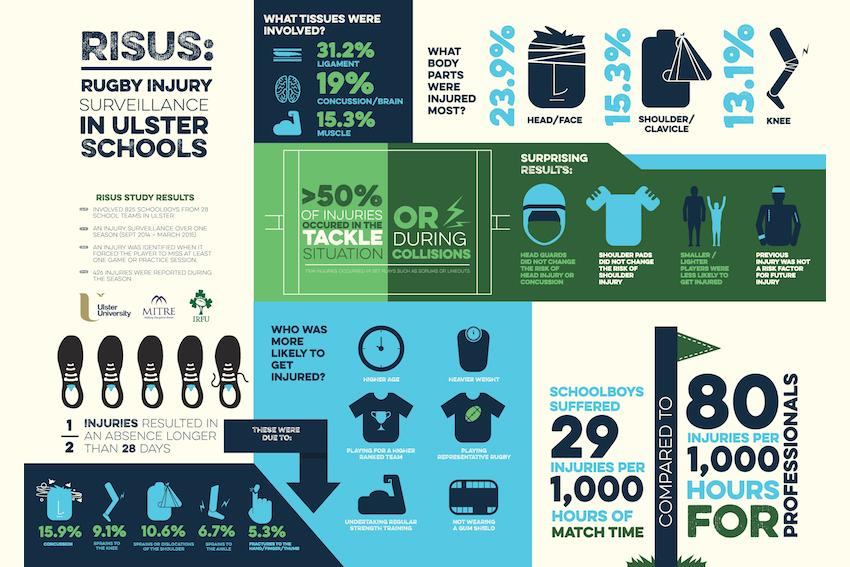Identify some key points in this picture. The tissue that had the least chance of being injured was muscle. The study found that the head had the highest percentage of injuries among the three body parts under consideration, shoulder, knee, and head. The number of injuries suffered by professionals is significantly different from that of school boys, with professionals experiencing 51 more injuries on average. 